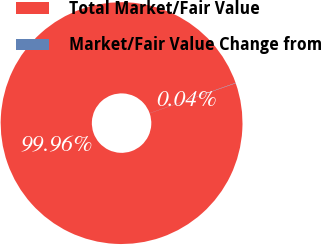Convert chart. <chart><loc_0><loc_0><loc_500><loc_500><pie_chart><fcel>Total Market/Fair Value<fcel>Market/Fair Value Change from<nl><fcel>99.96%<fcel>0.04%<nl></chart> 